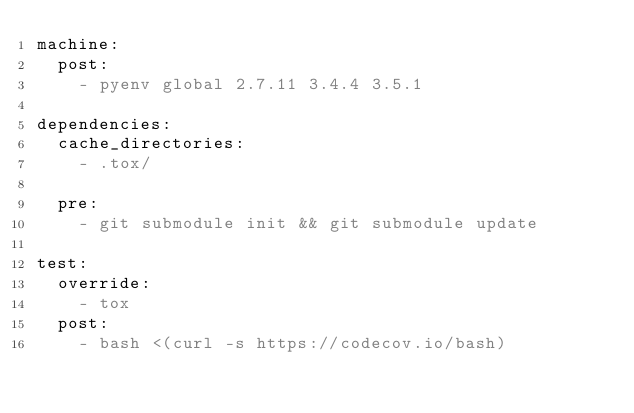Convert code to text. <code><loc_0><loc_0><loc_500><loc_500><_YAML_>machine:
  post:
    - pyenv global 2.7.11 3.4.4 3.5.1

dependencies:
  cache_directories:
    - .tox/

  pre:
    - git submodule init && git submodule update

test:
  override:
    - tox
  post:
    - bash <(curl -s https://codecov.io/bash)
</code> 